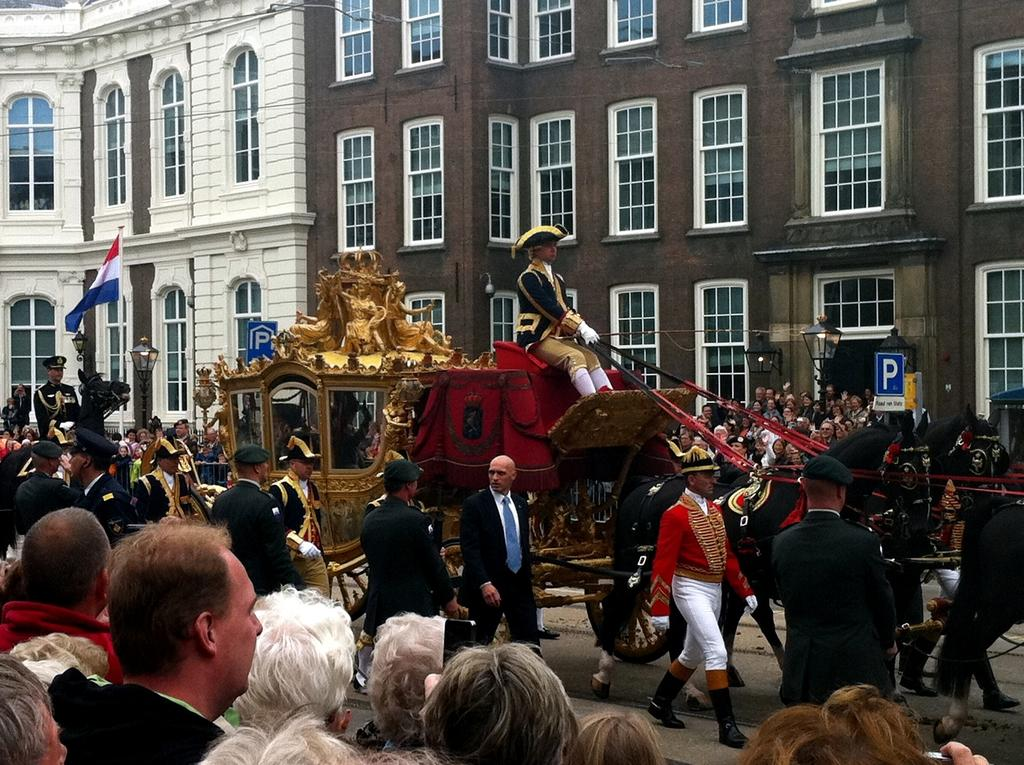What is the main subject of the image? There is a royal carriage in the image. Where is the carriage located? The carriage is on the road. Are there any people in the image? Yes, there are people watching the carriage. What can be seen in the background of the image? There are buildings in the background of the image. Can you tell me how many rats are running around the carriage in the image? There are no rats present in the image; the focus is on the royal carriage and the people watching it. What type of transport is being used by the people in the image? The image does not show any other form of transport besides the royal carriage. 